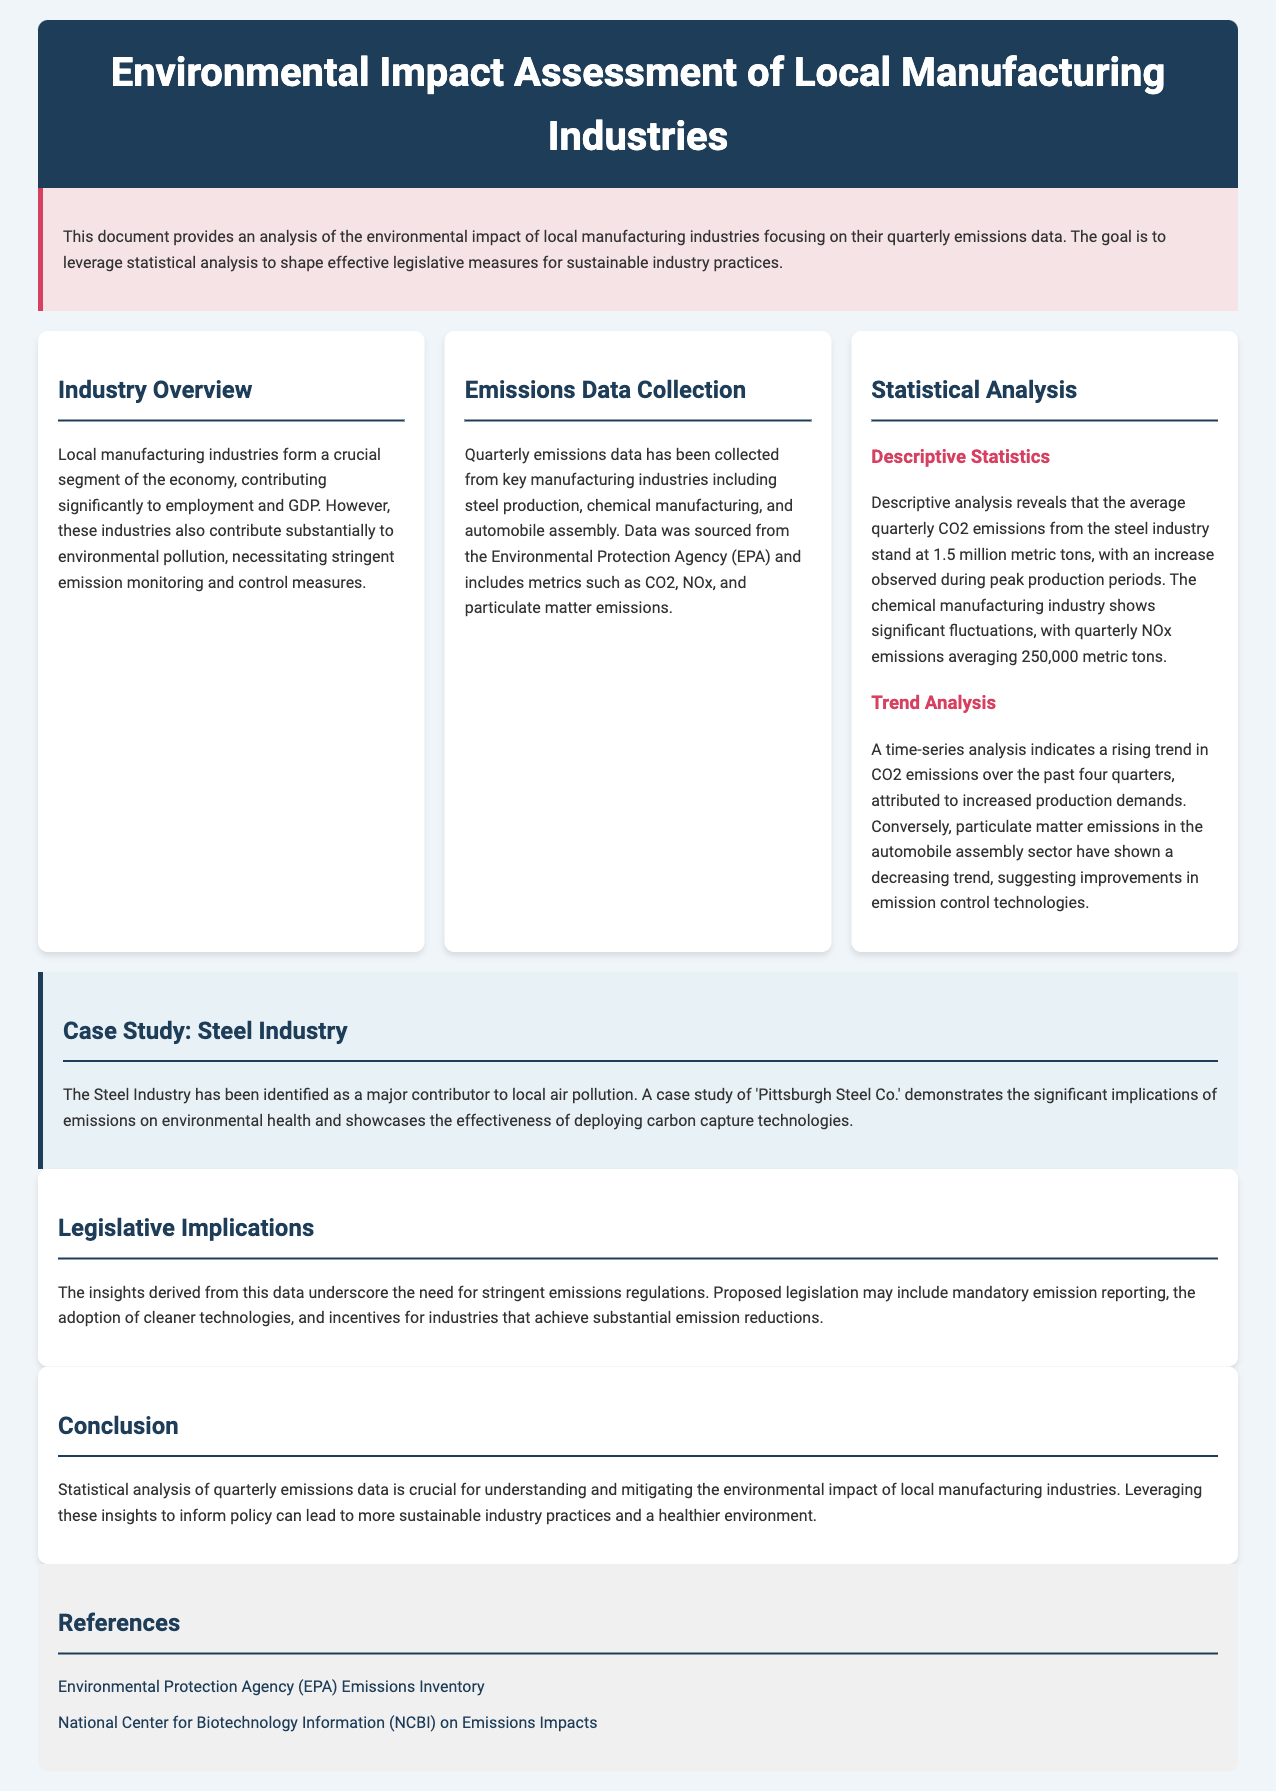What is the focus of the analysis? The analysis focuses on the environmental impact of local manufacturing industries and their quarterly emissions data.
Answer: environmental impact of local manufacturing industries and quarterly emissions data What is the average quarterly CO2 emissions for the steel industry? The document specifies that the average quarterly CO2 emissions from the steel industry stand at 1.5 million metric tons.
Answer: 1.5 million metric tons What significant trend is observed in CO2 emissions? A time-series analysis indicates a rising trend in CO2 emissions over the past four quarters due to increased production demands.
Answer: rising trend Which industry shows significant fluctuations in NOx emissions? The document mentions that the chemical manufacturing industry shows significant fluctuations in NOx emissions.
Answer: chemical manufacturing industry What technology is highlighted in the case study of the Steel Industry? The case study showcases the effectiveness of deploying carbon capture technologies in the Steel Industry.
Answer: carbon capture technologies What is a proposed legislative measure? Proposed legislation may include mandatory emission reporting according to the document.
Answer: mandatory emission reporting How are particulate matter emissions in the automobile assembly sector trending? The document notes that particulate matter emissions in the automobile assembly sector have shown a decreasing trend.
Answer: decreasing trend Which organization provided the emissions data? The data was sourced from the Environmental Protection Agency (EPA).
Answer: Environmental Protection Agency (EPA) What is a key implication of the insights derived from the data? The insights underscore the need for stringent emissions regulations.
Answer: stringent emissions regulations 